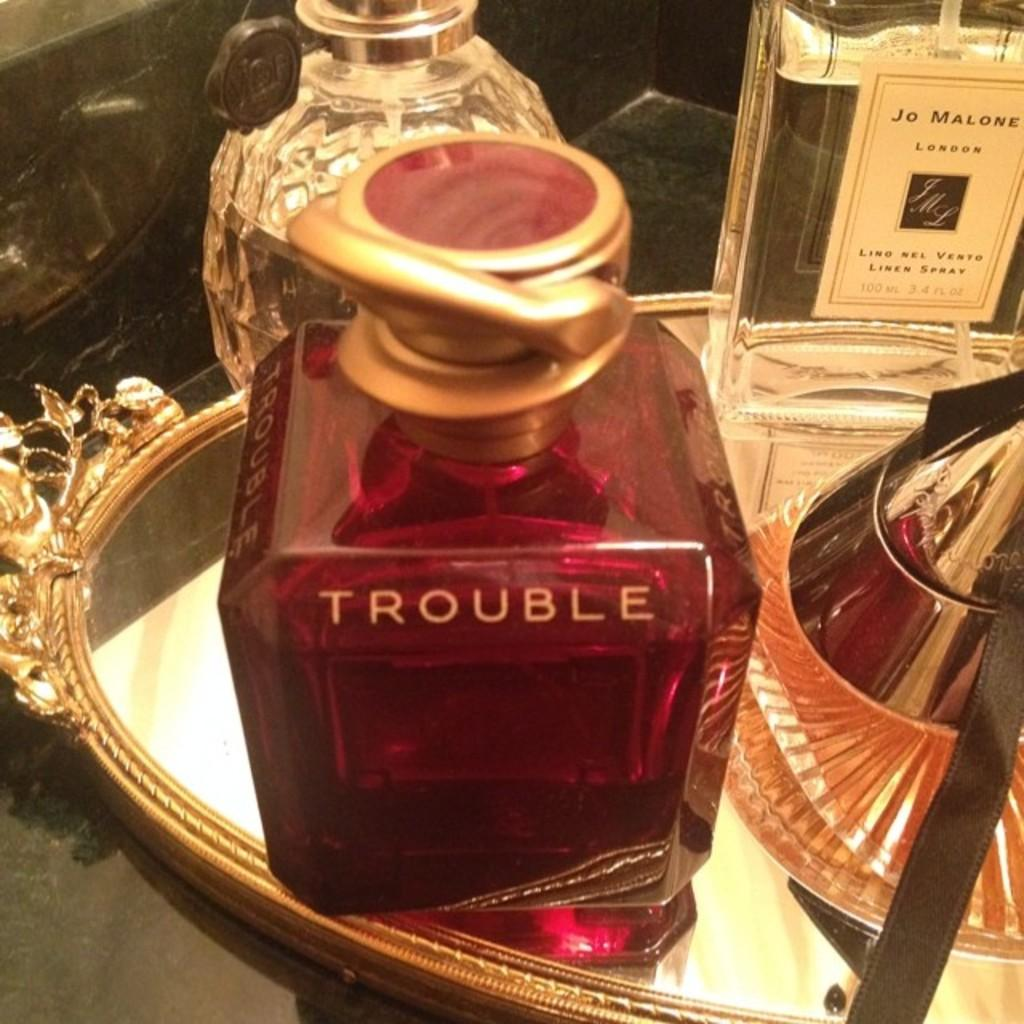<image>
Provide a brief description of the given image. A bottle of perfume with the word Trouble written on it 